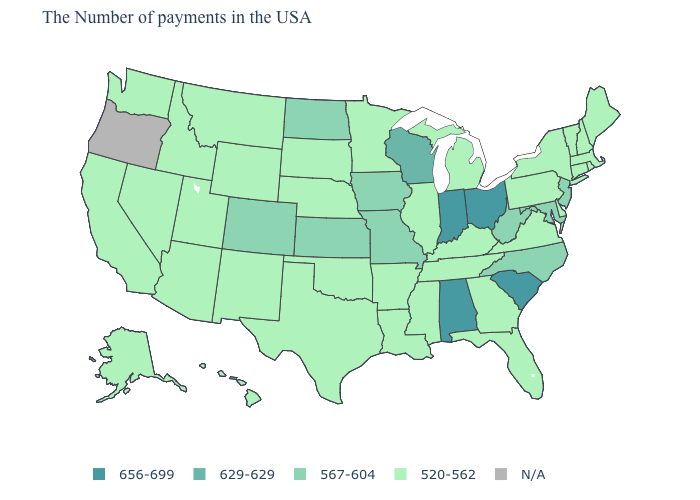What is the value of Iowa?
Keep it brief. 567-604. Which states have the lowest value in the MidWest?
Keep it brief. Michigan, Illinois, Minnesota, Nebraska, South Dakota. Among the states that border Wyoming , which have the lowest value?
Write a very short answer. Nebraska, South Dakota, Utah, Montana, Idaho. Name the states that have a value in the range N/A?
Short answer required. Oregon. Name the states that have a value in the range 567-604?
Be succinct. New Jersey, Maryland, North Carolina, West Virginia, Missouri, Iowa, Kansas, North Dakota, Colorado. Name the states that have a value in the range 656-699?
Quick response, please. South Carolina, Ohio, Indiana, Alabama. What is the value of Iowa?
Short answer required. 567-604. What is the lowest value in states that border Rhode Island?
Give a very brief answer. 520-562. Does North Carolina have the lowest value in the South?
Write a very short answer. No. What is the lowest value in the South?
Write a very short answer. 520-562. Which states hav the highest value in the MidWest?
Be succinct. Ohio, Indiana. Among the states that border Nebraska , which have the highest value?
Keep it brief. Missouri, Iowa, Kansas, Colorado. How many symbols are there in the legend?
Give a very brief answer. 5. 